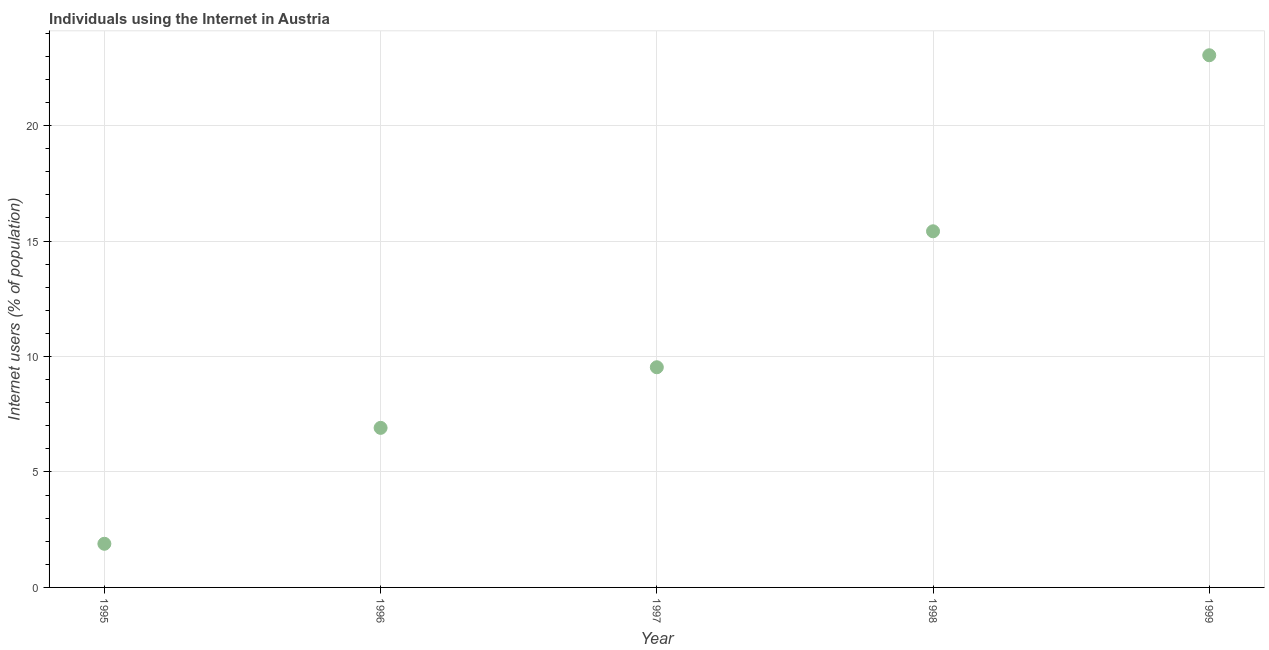What is the number of internet users in 1995?
Give a very brief answer. 1.89. Across all years, what is the maximum number of internet users?
Give a very brief answer. 23.04. Across all years, what is the minimum number of internet users?
Your answer should be very brief. 1.89. In which year was the number of internet users maximum?
Provide a succinct answer. 1999. In which year was the number of internet users minimum?
Provide a short and direct response. 1995. What is the sum of the number of internet users?
Offer a very short reply. 56.8. What is the difference between the number of internet users in 1995 and 1998?
Provide a short and direct response. -13.53. What is the average number of internet users per year?
Give a very brief answer. 11.36. What is the median number of internet users?
Provide a succinct answer. 9.53. Do a majority of the years between 1999 and 1997 (inclusive) have number of internet users greater than 21 %?
Make the answer very short. No. What is the ratio of the number of internet users in 1998 to that in 1999?
Keep it short and to the point. 0.67. Is the difference between the number of internet users in 1998 and 1999 greater than the difference between any two years?
Your response must be concise. No. What is the difference between the highest and the second highest number of internet users?
Ensure brevity in your answer.  7.62. Is the sum of the number of internet users in 1998 and 1999 greater than the maximum number of internet users across all years?
Your response must be concise. Yes. What is the difference between the highest and the lowest number of internet users?
Provide a short and direct response. 21.15. In how many years, is the number of internet users greater than the average number of internet users taken over all years?
Make the answer very short. 2. How many dotlines are there?
Your answer should be very brief. 1. How many years are there in the graph?
Keep it short and to the point. 5. What is the difference between two consecutive major ticks on the Y-axis?
Provide a succinct answer. 5. Are the values on the major ticks of Y-axis written in scientific E-notation?
Your answer should be compact. No. What is the title of the graph?
Offer a terse response. Individuals using the Internet in Austria. What is the label or title of the X-axis?
Your answer should be very brief. Year. What is the label or title of the Y-axis?
Make the answer very short. Internet users (% of population). What is the Internet users (% of population) in 1995?
Make the answer very short. 1.89. What is the Internet users (% of population) in 1996?
Your answer should be compact. 6.91. What is the Internet users (% of population) in 1997?
Give a very brief answer. 9.53. What is the Internet users (% of population) in 1998?
Your response must be concise. 15.42. What is the Internet users (% of population) in 1999?
Provide a short and direct response. 23.04. What is the difference between the Internet users (% of population) in 1995 and 1996?
Give a very brief answer. -5.02. What is the difference between the Internet users (% of population) in 1995 and 1997?
Your answer should be very brief. -7.64. What is the difference between the Internet users (% of population) in 1995 and 1998?
Your answer should be compact. -13.53. What is the difference between the Internet users (% of population) in 1995 and 1999?
Provide a succinct answer. -21.15. What is the difference between the Internet users (% of population) in 1996 and 1997?
Offer a very short reply. -2.62. What is the difference between the Internet users (% of population) in 1996 and 1998?
Ensure brevity in your answer.  -8.51. What is the difference between the Internet users (% of population) in 1996 and 1999?
Your answer should be very brief. -16.14. What is the difference between the Internet users (% of population) in 1997 and 1998?
Give a very brief answer. -5.89. What is the difference between the Internet users (% of population) in 1997 and 1999?
Make the answer very short. -13.51. What is the difference between the Internet users (% of population) in 1998 and 1999?
Offer a terse response. -7.62. What is the ratio of the Internet users (% of population) in 1995 to that in 1996?
Make the answer very short. 0.27. What is the ratio of the Internet users (% of population) in 1995 to that in 1997?
Make the answer very short. 0.2. What is the ratio of the Internet users (% of population) in 1995 to that in 1998?
Offer a terse response. 0.12. What is the ratio of the Internet users (% of population) in 1995 to that in 1999?
Make the answer very short. 0.08. What is the ratio of the Internet users (% of population) in 1996 to that in 1997?
Offer a terse response. 0.72. What is the ratio of the Internet users (% of population) in 1996 to that in 1998?
Your answer should be compact. 0.45. What is the ratio of the Internet users (% of population) in 1996 to that in 1999?
Offer a very short reply. 0.3. What is the ratio of the Internet users (% of population) in 1997 to that in 1998?
Give a very brief answer. 0.62. What is the ratio of the Internet users (% of population) in 1997 to that in 1999?
Provide a short and direct response. 0.41. What is the ratio of the Internet users (% of population) in 1998 to that in 1999?
Offer a very short reply. 0.67. 